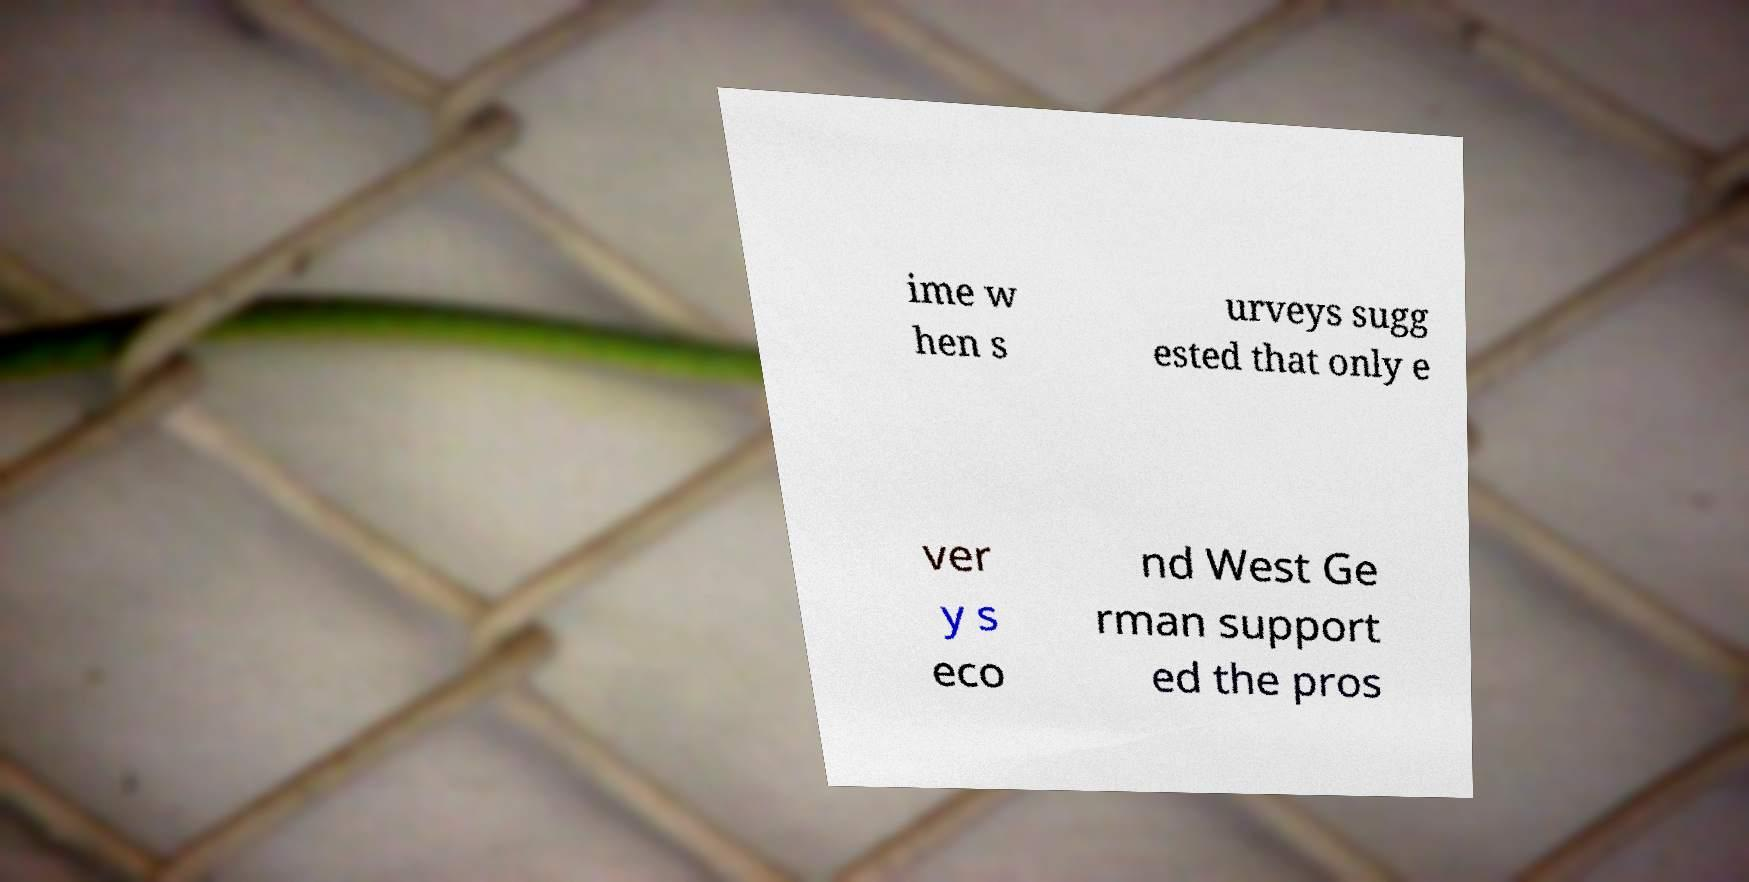There's text embedded in this image that I need extracted. Can you transcribe it verbatim? ime w hen s urveys sugg ested that only e ver y s eco nd West Ge rman support ed the pros 